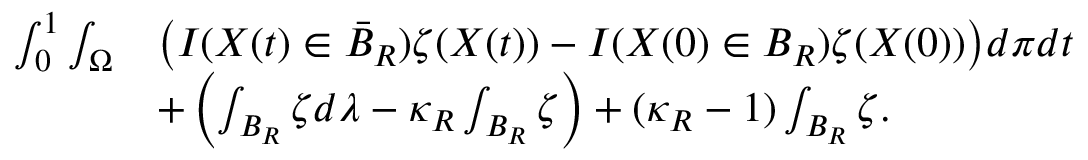<formula> <loc_0><loc_0><loc_500><loc_500>\begin{array} { r l } { \int _ { 0 } ^ { 1 } \int _ { \Omega } } & { \left ( I ( X ( t ) \in \bar { B } _ { R } ) \zeta ( X ( t ) ) - I ( X ( 0 ) \in B _ { R } ) \zeta ( X ( 0 ) ) \right ) d \pi d t } \\ & { + \left ( \int _ { B _ { R } } \zeta d \lambda - \kappa _ { R } \int _ { B _ { R } } \zeta \right ) + ( \kappa _ { R } - 1 ) \int _ { B _ { R } } \zeta . } \end{array}</formula> 